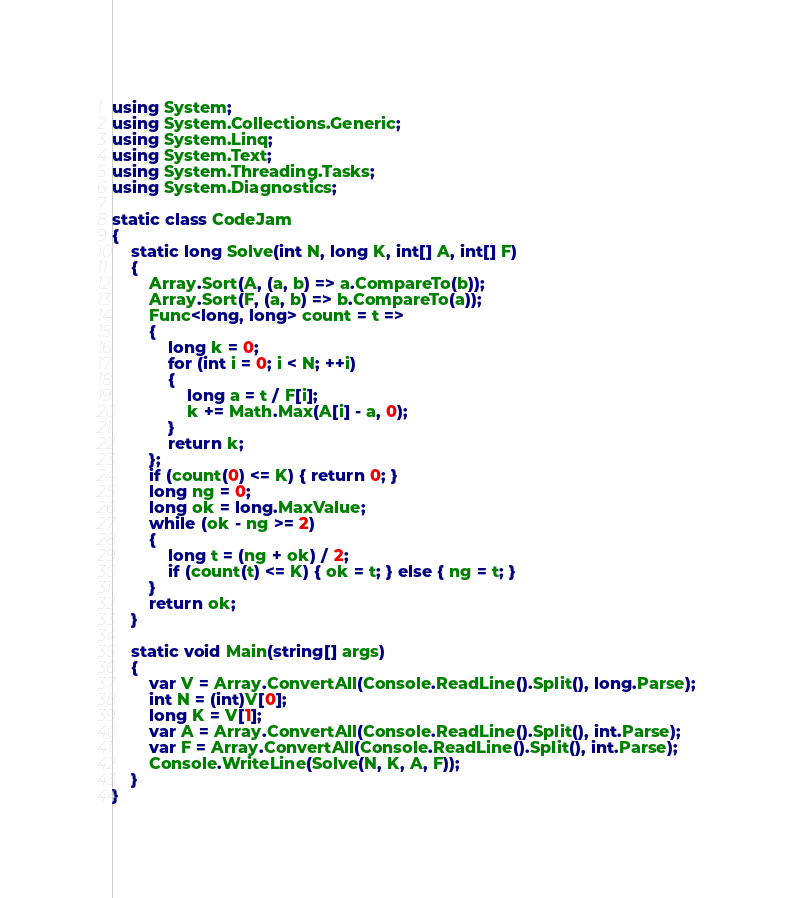<code> <loc_0><loc_0><loc_500><loc_500><_C#_>using System;
using System.Collections.Generic;
using System.Linq;
using System.Text;
using System.Threading.Tasks;
using System.Diagnostics;

static class CodeJam
{
    static long Solve(int N, long K, int[] A, int[] F)
    {
        Array.Sort(A, (a, b) => a.CompareTo(b));
        Array.Sort(F, (a, b) => b.CompareTo(a));
        Func<long, long> count = t =>
        {
            long k = 0;
            for (int i = 0; i < N; ++i)
            {
                long a = t / F[i];
                k += Math.Max(A[i] - a, 0);
            }
            return k;
        };
        if (count(0) <= K) { return 0; }
        long ng = 0;
        long ok = long.MaxValue;
        while (ok - ng >= 2)
        {
            long t = (ng + ok) / 2;
            if (count(t) <= K) { ok = t; } else { ng = t; }
        }
        return ok;
    }

    static void Main(string[] args)
    {
        var V = Array.ConvertAll(Console.ReadLine().Split(), long.Parse);
        int N = (int)V[0];
        long K = V[1];
        var A = Array.ConvertAll(Console.ReadLine().Split(), int.Parse);
        var F = Array.ConvertAll(Console.ReadLine().Split(), int.Parse);
        Console.WriteLine(Solve(N, K, A, F));
    }
}
</code> 